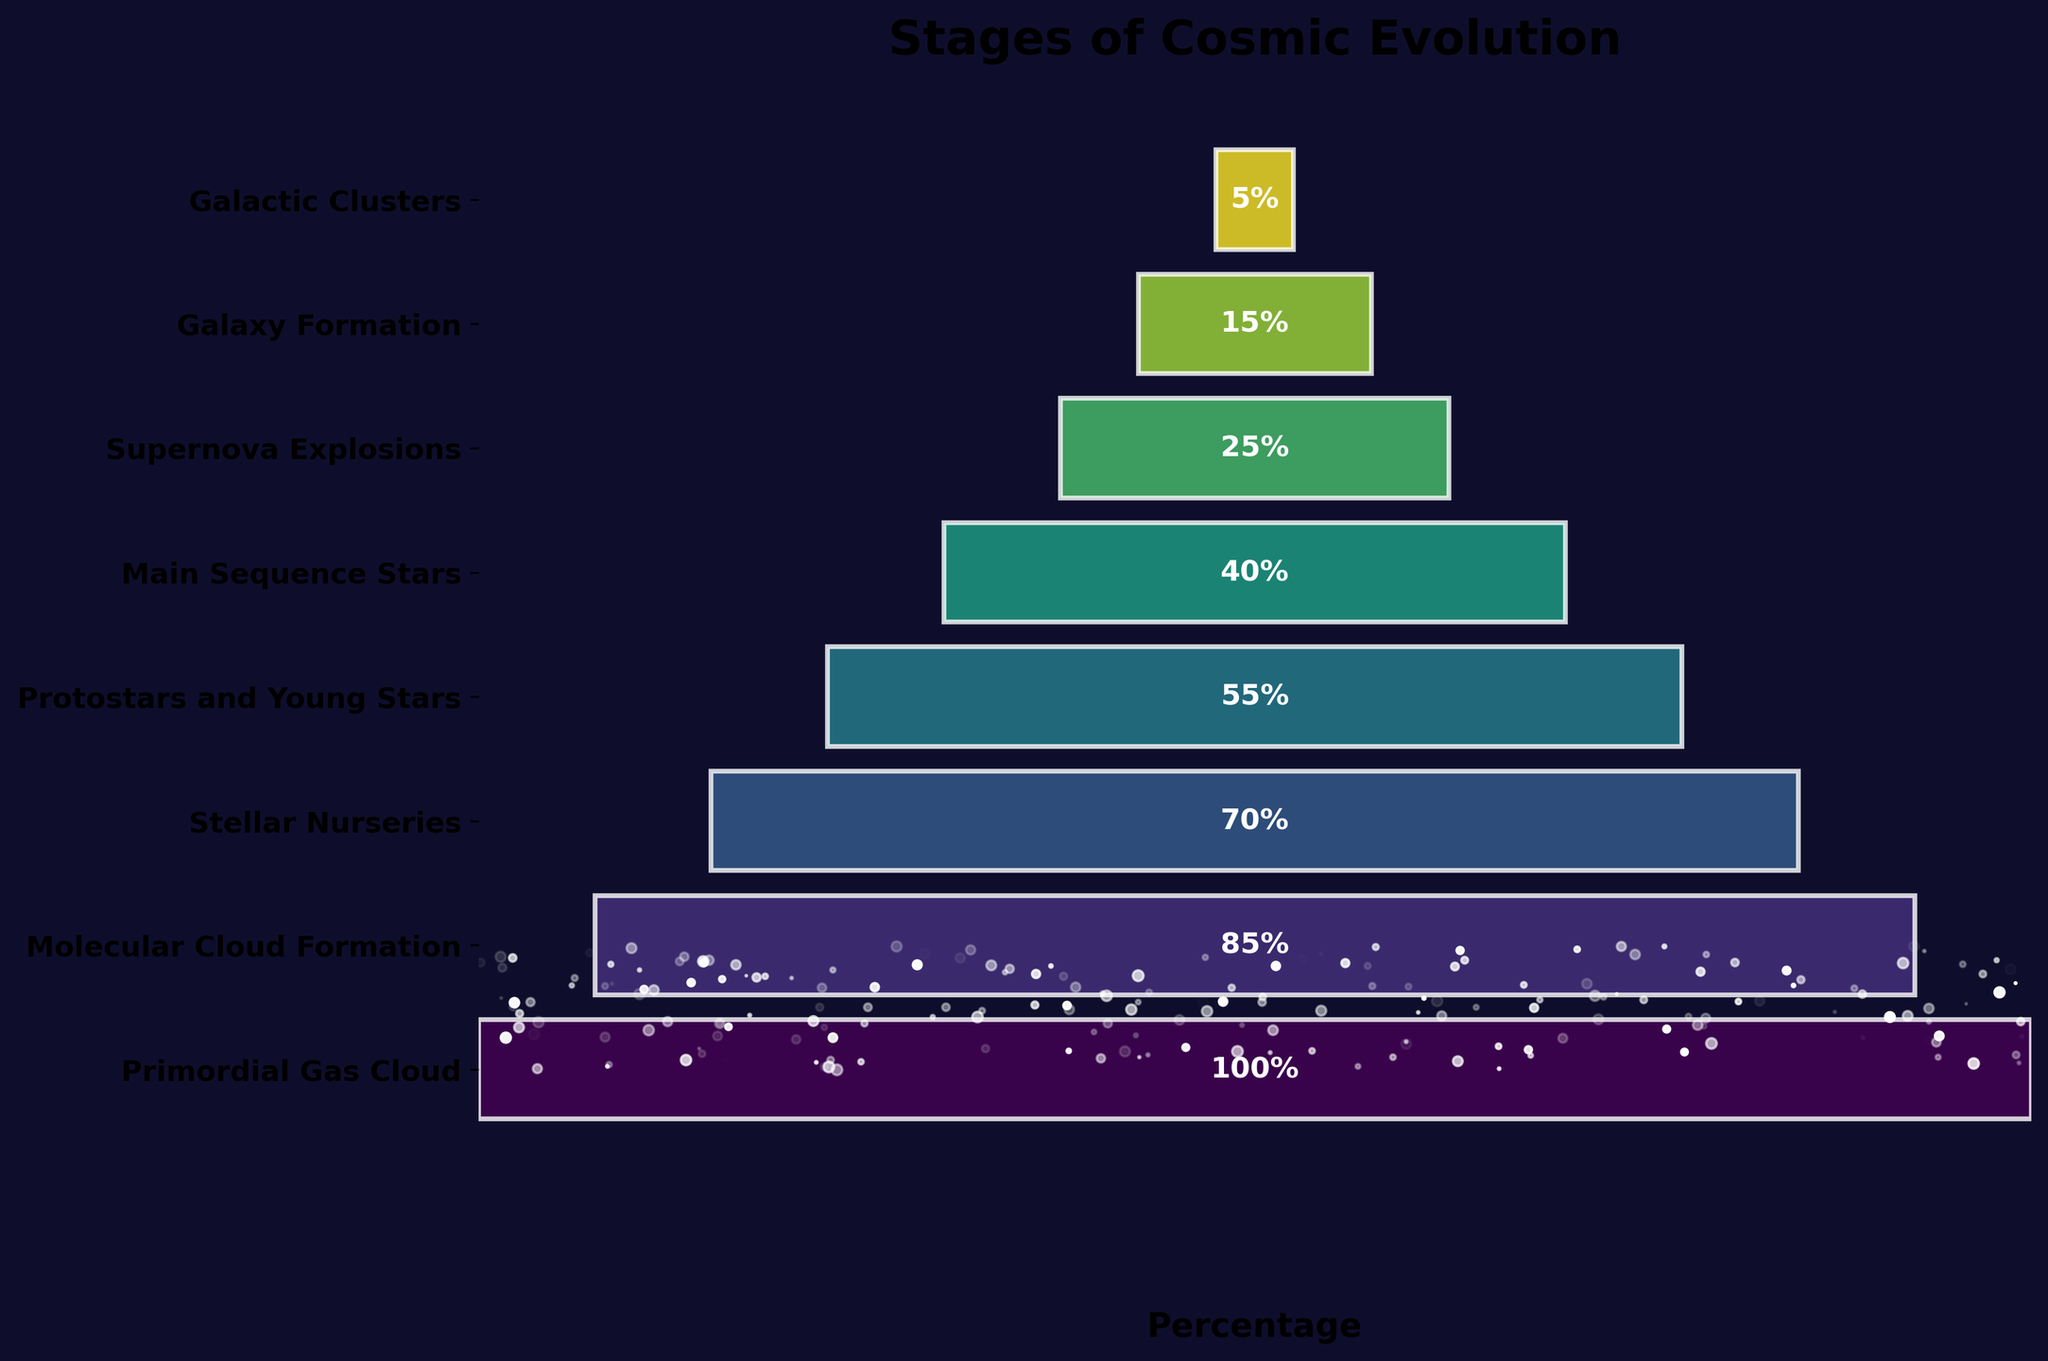What is the title of the funnel chart? The title is represented as the most prominent text at the top of the figure. It gives an overview of what the chart represents.
Answer: Stages of Cosmic Evolution Which stage has the highest percentage? The stage with the highest percentage appears at the widest part of the funnel and often displays the largest percentage label.
Answer: Primordial Gas Cloud How many stages are illustrated in the funnel chart? By counting the distinct segments or bars in the funnel chart from top to bottom, we get the total number of stages.
Answer: 8 What percentage of molecular cloud formation is represented in the chart? Look for the width size labeled as "Molecular Cloud Formation" and check the percentage label inside the bar.
Answer: 85% What is the percentage difference between Protostars and Young Stars and Main Sequence Stars? Subtract the percentage of Main Sequence Stars from the percentage of Protostars and Young Stars (55 - 40).
Answer: 15% Which stage occupies the middle position in the chart? Identify the stage placed in the central part of the figure. This stage often splits the chart evenly.
Answer: Protostars and Young Stars How does the percentage of Galaxy Formation compare to that of Supernova Explosions? Compare the percentages of the stages "Galaxy Formation" and "Supernova Explosions."
Answer: Galaxy Formation has a lower percentage (15%) than Supernova Explosions (25%) Which stages have more than 50% in the chart? Identify the stages where the associated percentage labels are greater than 50%.
Answer: Primordial Gas Cloud, Molecular Cloud Formation, Stellar Nurseries, Protostars, and Young Stars What stages are represented by a percentage lower than 20%? Identify stages with percentage labels less than 20%.
Answer: Galaxy Formation, Galactic Clusters How does the color scheme of the funnel chart vary through the stages? The color changes according to a gradient applied across the chart. Notice how colors transition from the top to the bottom of the chart.
Answer: The colors gradually shift from dark green to light green 